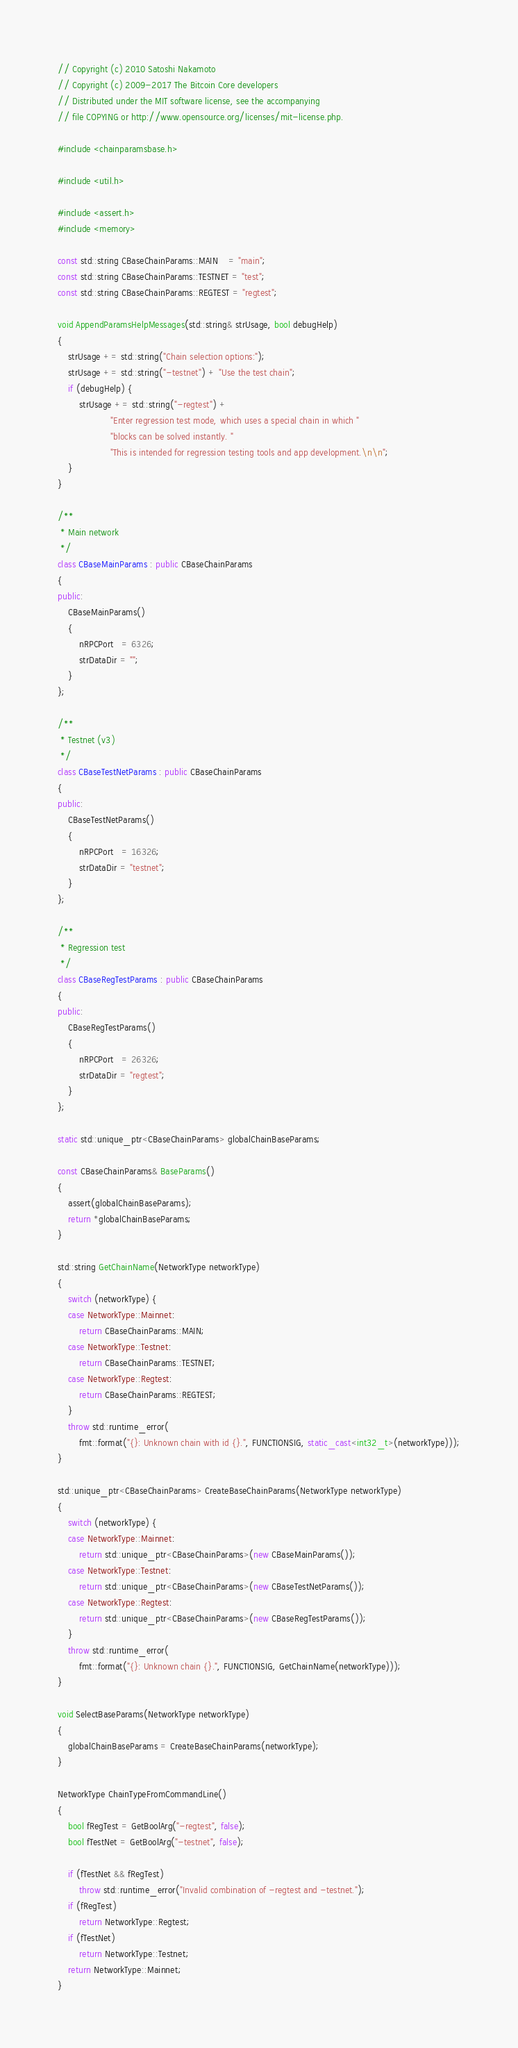<code> <loc_0><loc_0><loc_500><loc_500><_C++_>// Copyright (c) 2010 Satoshi Nakamoto
// Copyright (c) 2009-2017 The Bitcoin Core developers
// Distributed under the MIT software license, see the accompanying
// file COPYING or http://www.opensource.org/licenses/mit-license.php.

#include <chainparamsbase.h>

#include <util.h>

#include <assert.h>
#include <memory>

const std::string CBaseChainParams::MAIN    = "main";
const std::string CBaseChainParams::TESTNET = "test";
const std::string CBaseChainParams::REGTEST = "regtest";

void AppendParamsHelpMessages(std::string& strUsage, bool debugHelp)
{
    strUsage += std::string("Chain selection options:");
    strUsage += std::string("-testnet") + "Use the test chain";
    if (debugHelp) {
        strUsage += std::string("-regtest") +
                    "Enter regression test mode, which uses a special chain in which "
                    "blocks can be solved instantly. "
                    "This is intended for regression testing tools and app development.\n\n";
    }
}

/**
 * Main network
 */
class CBaseMainParams : public CBaseChainParams
{
public:
    CBaseMainParams()
    {
        nRPCPort   = 6326;
        strDataDir = "";
    }
};

/**
 * Testnet (v3)
 */
class CBaseTestNetParams : public CBaseChainParams
{
public:
    CBaseTestNetParams()
    {
        nRPCPort   = 16326;
        strDataDir = "testnet";
    }
};

/**
 * Regression test
 */
class CBaseRegTestParams : public CBaseChainParams
{
public:
    CBaseRegTestParams()
    {
        nRPCPort   = 26326;
        strDataDir = "regtest";
    }
};

static std::unique_ptr<CBaseChainParams> globalChainBaseParams;

const CBaseChainParams& BaseParams()
{
    assert(globalChainBaseParams);
    return *globalChainBaseParams;
}

std::string GetChainName(NetworkType networkType)
{
    switch (networkType) {
    case NetworkType::Mainnet:
        return CBaseChainParams::MAIN;
    case NetworkType::Testnet:
        return CBaseChainParams::TESTNET;
    case NetworkType::Regtest:
        return CBaseChainParams::REGTEST;
    }
    throw std::runtime_error(
        fmt::format("{}: Unknown chain with id {}.", FUNCTIONSIG, static_cast<int32_t>(networkType)));
}

std::unique_ptr<CBaseChainParams> CreateBaseChainParams(NetworkType networkType)
{
    switch (networkType) {
    case NetworkType::Mainnet:
        return std::unique_ptr<CBaseChainParams>(new CBaseMainParams());
    case NetworkType::Testnet:
        return std::unique_ptr<CBaseChainParams>(new CBaseTestNetParams());
    case NetworkType::Regtest:
        return std::unique_ptr<CBaseChainParams>(new CBaseRegTestParams());
    }
    throw std::runtime_error(
        fmt::format("{}: Unknown chain {}.", FUNCTIONSIG, GetChainName(networkType)));
}

void SelectBaseParams(NetworkType networkType)
{
    globalChainBaseParams = CreateBaseChainParams(networkType);
}

NetworkType ChainTypeFromCommandLine()
{
    bool fRegTest = GetBoolArg("-regtest", false);
    bool fTestNet = GetBoolArg("-testnet", false);

    if (fTestNet && fRegTest)
        throw std::runtime_error("Invalid combination of -regtest and -testnet.");
    if (fRegTest)
        return NetworkType::Regtest;
    if (fTestNet)
        return NetworkType::Testnet;
    return NetworkType::Mainnet;
}
</code> 